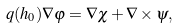<formula> <loc_0><loc_0><loc_500><loc_500>q ( h _ { 0 } ) \nabla \varphi = \nabla \chi + \nabla \times \psi ,</formula> 